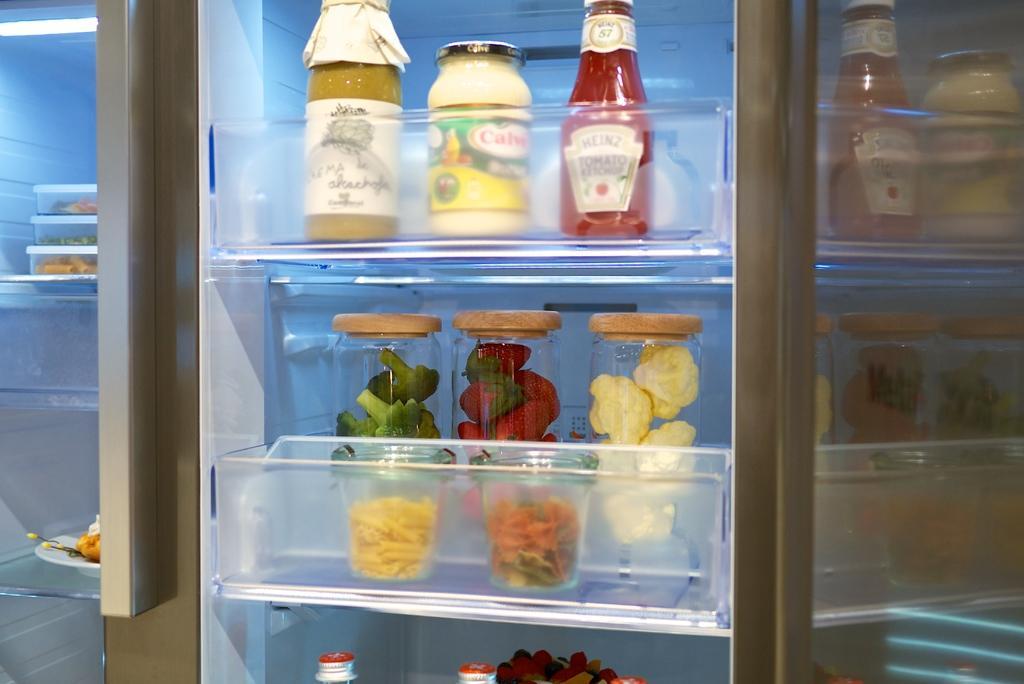In one or two sentences, can you explain what this image depicts? there is a picture of a refrigerator in which there are many bottles with the food items. 